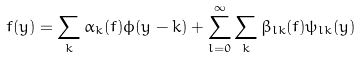<formula> <loc_0><loc_0><loc_500><loc_500>f ( y ) = \sum _ { k } \alpha _ { k } ( f ) \phi ( y - k ) + \sum _ { l = 0 } ^ { \infty } \sum _ { k } \beta _ { l k } ( f ) \psi _ { l k } ( y )</formula> 